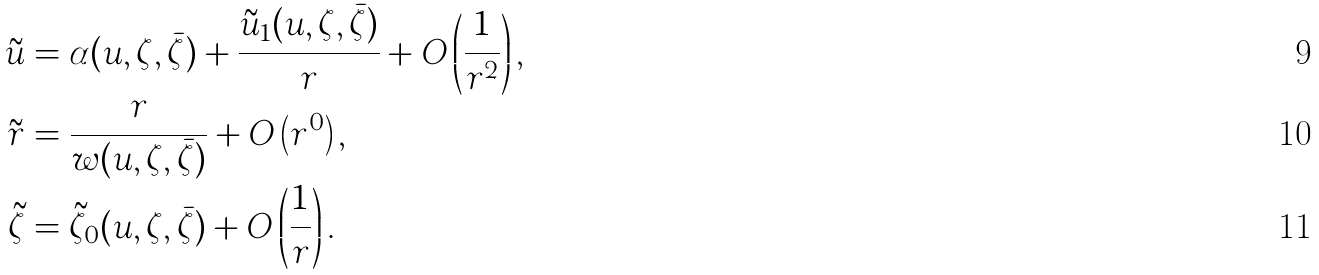Convert formula to latex. <formula><loc_0><loc_0><loc_500><loc_500>\tilde { u } & = \alpha ( u , \zeta , \bar { \zeta } ) + \frac { \tilde { u } _ { 1 } ( u , \zeta , \bar { \zeta } ) } { r } + O \left ( \frac { 1 } { r ^ { 2 } } \right ) , \\ \tilde { r } & = \frac { r } { w ( u , \zeta , \bar { \zeta } ) } + O \left ( r ^ { 0 } \right ) , \\ \tilde { \zeta } & = \tilde { \zeta } _ { 0 } ( u , \zeta , \bar { \zeta } ) + O \left ( \frac { 1 } { r } \right ) .</formula> 